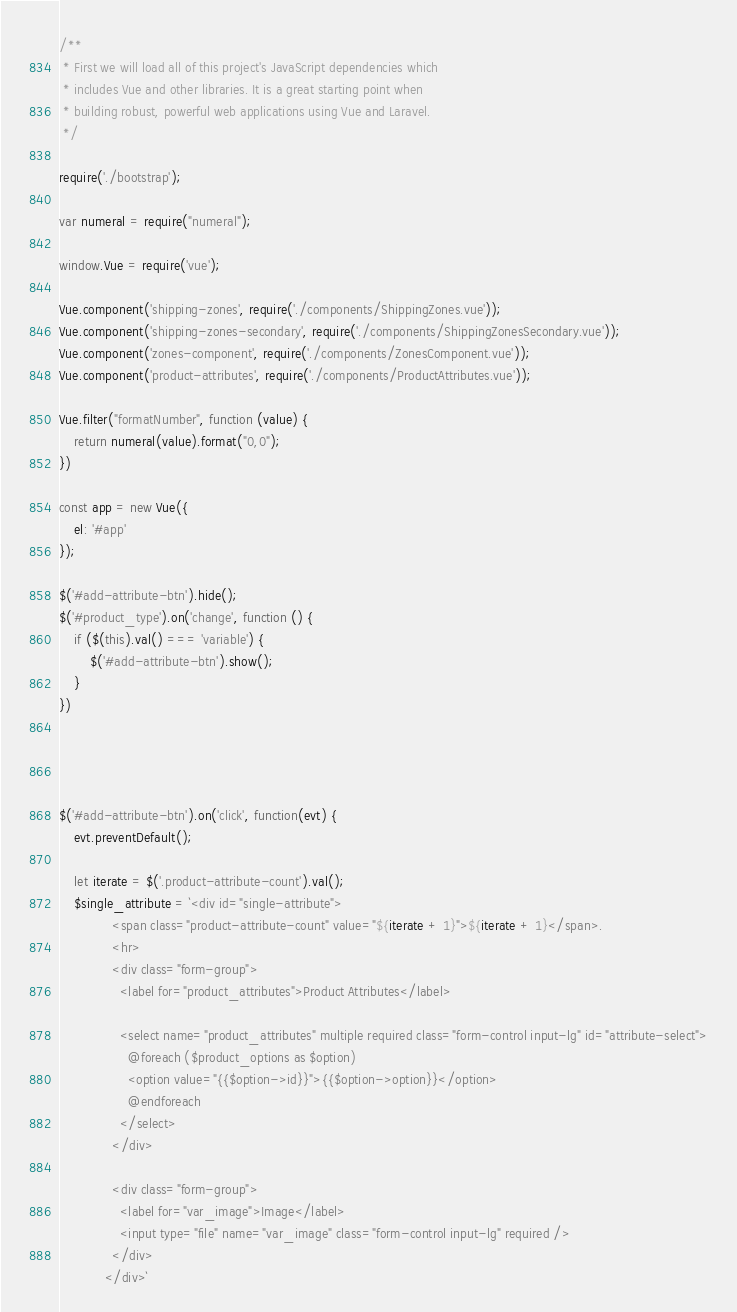Convert code to text. <code><loc_0><loc_0><loc_500><loc_500><_JavaScript_>/**
 * First we will load all of this project's JavaScript dependencies which
 * includes Vue and other libraries. It is a great starting point when
 * building robust, powerful web applications using Vue and Laravel.
 */

require('./bootstrap');

var numeral = require("numeral");

window.Vue = require('vue');

Vue.component('shipping-zones', require('./components/ShippingZones.vue'));
Vue.component('shipping-zones-secondary', require('./components/ShippingZonesSecondary.vue'));
Vue.component('zones-component', require('./components/ZonesComponent.vue'));
Vue.component('product-attributes', require('./components/ProductAttributes.vue'));

Vue.filter("formatNumber", function (value) {
    return numeral(value).format("0,0");
})

const app = new Vue({
    el: '#app'
});

$('#add-attribute-btn').hide();
$('#product_type').on('change', function () {
    if ($(this).val() === 'variable') {
        $('#add-attribute-btn').show();
    }
})




$('#add-attribute-btn').on('click', function(evt) {
    evt.preventDefault();

    let iterate = $('.product-attribute-count').val();
    $single_attribute = `<div id="single-attribute">
              <span class="product-attribute-count" value="${iterate + 1}">${iterate + 1}</span>.
              <hr>
              <div class="form-group">
                <label for="product_attributes">Product Attributes</label>
                
                <select name="product_attributes" multiple required class="form-control input-lg" id="attribute-select">
                  @foreach ($product_options as $option)
                  <option value="{{$option->id}}">{{$option->option}}</option>
                  @endforeach
                </select>
              </div>
  
              <div class="form-group">
                <label for="var_image">Image</label>
                <input type="file" name="var_image" class="form-control input-lg" required />
              </div>
            </div>`</code> 